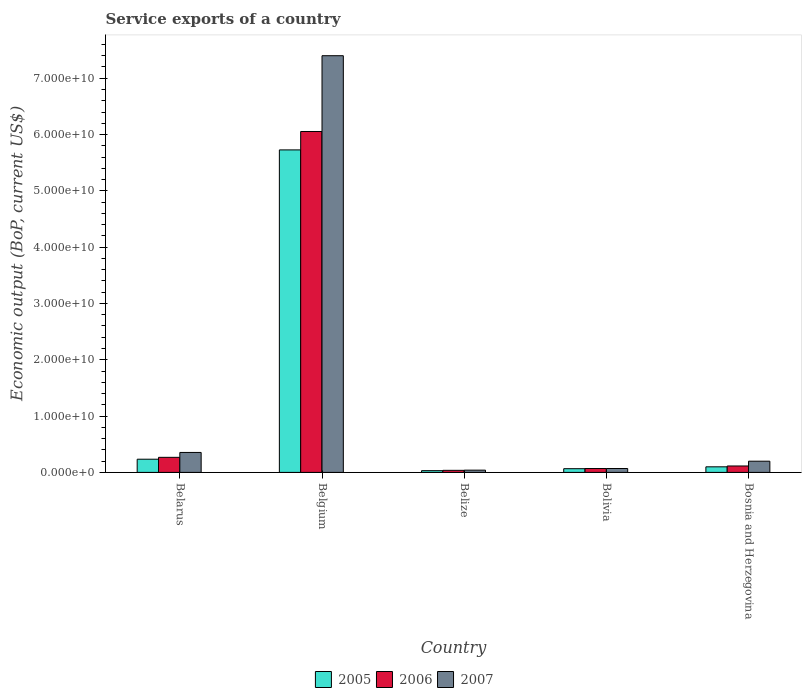How many different coloured bars are there?
Offer a very short reply. 3. How many groups of bars are there?
Provide a short and direct response. 5. Are the number of bars on each tick of the X-axis equal?
Provide a short and direct response. Yes. In how many cases, is the number of bars for a given country not equal to the number of legend labels?
Offer a very short reply. 0. What is the service exports in 2005 in Belgium?
Your answer should be compact. 5.73e+1. Across all countries, what is the maximum service exports in 2006?
Ensure brevity in your answer.  6.05e+1. Across all countries, what is the minimum service exports in 2006?
Ensure brevity in your answer.  3.67e+08. In which country was the service exports in 2007 maximum?
Give a very brief answer. Belgium. In which country was the service exports in 2005 minimum?
Your response must be concise. Belize. What is the total service exports in 2006 in the graph?
Your answer should be very brief. 6.54e+1. What is the difference between the service exports in 2007 in Belarus and that in Bolivia?
Your answer should be very brief. 2.85e+09. What is the difference between the service exports in 2007 in Bosnia and Herzegovina and the service exports in 2006 in Belize?
Provide a short and direct response. 1.62e+09. What is the average service exports in 2007 per country?
Keep it short and to the point. 1.61e+1. What is the difference between the service exports of/in 2006 and service exports of/in 2007 in Belize?
Your response must be concise. -3.31e+07. What is the ratio of the service exports in 2005 in Belarus to that in Belgium?
Offer a very short reply. 0.04. What is the difference between the highest and the second highest service exports in 2005?
Offer a very short reply. 1.35e+09. What is the difference between the highest and the lowest service exports in 2005?
Make the answer very short. 5.70e+1. Is the sum of the service exports in 2007 in Belarus and Belize greater than the maximum service exports in 2005 across all countries?
Your answer should be compact. No. What does the 2nd bar from the left in Bosnia and Herzegovina represents?
Provide a succinct answer. 2006. What does the 1st bar from the right in Bosnia and Herzegovina represents?
Your answer should be compact. 2007. Is it the case that in every country, the sum of the service exports in 2005 and service exports in 2007 is greater than the service exports in 2006?
Offer a very short reply. Yes. How many bars are there?
Your answer should be very brief. 15. How many countries are there in the graph?
Provide a succinct answer. 5. What is the difference between two consecutive major ticks on the Y-axis?
Your answer should be very brief. 1.00e+1. Are the values on the major ticks of Y-axis written in scientific E-notation?
Your answer should be very brief. Yes. Does the graph contain grids?
Provide a short and direct response. No. How are the legend labels stacked?
Offer a terse response. Horizontal. What is the title of the graph?
Your answer should be compact. Service exports of a country. Does "2008" appear as one of the legend labels in the graph?
Ensure brevity in your answer.  No. What is the label or title of the X-axis?
Make the answer very short. Country. What is the label or title of the Y-axis?
Make the answer very short. Economic output (BoP, current US$). What is the Economic output (BoP, current US$) of 2005 in Belarus?
Ensure brevity in your answer.  2.34e+09. What is the Economic output (BoP, current US$) of 2006 in Belarus?
Your answer should be compact. 2.67e+09. What is the Economic output (BoP, current US$) of 2007 in Belarus?
Provide a succinct answer. 3.54e+09. What is the Economic output (BoP, current US$) in 2005 in Belgium?
Make the answer very short. 5.73e+1. What is the Economic output (BoP, current US$) of 2006 in Belgium?
Your answer should be very brief. 6.05e+1. What is the Economic output (BoP, current US$) of 2007 in Belgium?
Give a very brief answer. 7.40e+1. What is the Economic output (BoP, current US$) of 2005 in Belize?
Give a very brief answer. 3.07e+08. What is the Economic output (BoP, current US$) of 2006 in Belize?
Your response must be concise. 3.67e+08. What is the Economic output (BoP, current US$) of 2007 in Belize?
Make the answer very short. 4.00e+08. What is the Economic output (BoP, current US$) of 2005 in Bolivia?
Offer a very short reply. 6.57e+08. What is the Economic output (BoP, current US$) in 2006 in Bolivia?
Your answer should be compact. 6.87e+08. What is the Economic output (BoP, current US$) of 2007 in Bolivia?
Offer a terse response. 6.92e+08. What is the Economic output (BoP, current US$) of 2005 in Bosnia and Herzegovina?
Give a very brief answer. 9.89e+08. What is the Economic output (BoP, current US$) in 2006 in Bosnia and Herzegovina?
Give a very brief answer. 1.14e+09. What is the Economic output (BoP, current US$) of 2007 in Bosnia and Herzegovina?
Offer a terse response. 1.99e+09. Across all countries, what is the maximum Economic output (BoP, current US$) in 2005?
Give a very brief answer. 5.73e+1. Across all countries, what is the maximum Economic output (BoP, current US$) of 2006?
Your answer should be compact. 6.05e+1. Across all countries, what is the maximum Economic output (BoP, current US$) in 2007?
Make the answer very short. 7.40e+1. Across all countries, what is the minimum Economic output (BoP, current US$) of 2005?
Your answer should be very brief. 3.07e+08. Across all countries, what is the minimum Economic output (BoP, current US$) of 2006?
Offer a very short reply. 3.67e+08. Across all countries, what is the minimum Economic output (BoP, current US$) in 2007?
Make the answer very short. 4.00e+08. What is the total Economic output (BoP, current US$) of 2005 in the graph?
Provide a short and direct response. 6.16e+1. What is the total Economic output (BoP, current US$) in 2006 in the graph?
Provide a succinct answer. 6.54e+1. What is the total Economic output (BoP, current US$) of 2007 in the graph?
Provide a short and direct response. 8.06e+1. What is the difference between the Economic output (BoP, current US$) of 2005 in Belarus and that in Belgium?
Make the answer very short. -5.49e+1. What is the difference between the Economic output (BoP, current US$) of 2006 in Belarus and that in Belgium?
Make the answer very short. -5.79e+1. What is the difference between the Economic output (BoP, current US$) in 2007 in Belarus and that in Belgium?
Offer a very short reply. -7.05e+1. What is the difference between the Economic output (BoP, current US$) of 2005 in Belarus and that in Belize?
Make the answer very short. 2.04e+09. What is the difference between the Economic output (BoP, current US$) in 2006 in Belarus and that in Belize?
Offer a very short reply. 2.31e+09. What is the difference between the Economic output (BoP, current US$) in 2007 in Belarus and that in Belize?
Provide a short and direct response. 3.14e+09. What is the difference between the Economic output (BoP, current US$) in 2005 in Belarus and that in Bolivia?
Your answer should be compact. 1.69e+09. What is the difference between the Economic output (BoP, current US$) of 2006 in Belarus and that in Bolivia?
Give a very brief answer. 1.99e+09. What is the difference between the Economic output (BoP, current US$) of 2007 in Belarus and that in Bolivia?
Provide a succinct answer. 2.85e+09. What is the difference between the Economic output (BoP, current US$) in 2005 in Belarus and that in Bosnia and Herzegovina?
Your answer should be compact. 1.35e+09. What is the difference between the Economic output (BoP, current US$) in 2006 in Belarus and that in Bosnia and Herzegovina?
Give a very brief answer. 1.53e+09. What is the difference between the Economic output (BoP, current US$) in 2007 in Belarus and that in Bosnia and Herzegovina?
Offer a terse response. 1.55e+09. What is the difference between the Economic output (BoP, current US$) in 2005 in Belgium and that in Belize?
Your answer should be very brief. 5.70e+1. What is the difference between the Economic output (BoP, current US$) of 2006 in Belgium and that in Belize?
Your answer should be very brief. 6.02e+1. What is the difference between the Economic output (BoP, current US$) in 2007 in Belgium and that in Belize?
Your response must be concise. 7.36e+1. What is the difference between the Economic output (BoP, current US$) of 2005 in Belgium and that in Bolivia?
Provide a succinct answer. 5.66e+1. What is the difference between the Economic output (BoP, current US$) of 2006 in Belgium and that in Bolivia?
Your answer should be compact. 5.99e+1. What is the difference between the Economic output (BoP, current US$) in 2007 in Belgium and that in Bolivia?
Keep it short and to the point. 7.33e+1. What is the difference between the Economic output (BoP, current US$) in 2005 in Belgium and that in Bosnia and Herzegovina?
Make the answer very short. 5.63e+1. What is the difference between the Economic output (BoP, current US$) in 2006 in Belgium and that in Bosnia and Herzegovina?
Your answer should be compact. 5.94e+1. What is the difference between the Economic output (BoP, current US$) of 2007 in Belgium and that in Bosnia and Herzegovina?
Provide a short and direct response. 7.20e+1. What is the difference between the Economic output (BoP, current US$) in 2005 in Belize and that in Bolivia?
Your response must be concise. -3.50e+08. What is the difference between the Economic output (BoP, current US$) of 2006 in Belize and that in Bolivia?
Your answer should be compact. -3.20e+08. What is the difference between the Economic output (BoP, current US$) in 2007 in Belize and that in Bolivia?
Provide a short and direct response. -2.92e+08. What is the difference between the Economic output (BoP, current US$) of 2005 in Belize and that in Bosnia and Herzegovina?
Your answer should be compact. -6.82e+08. What is the difference between the Economic output (BoP, current US$) in 2006 in Belize and that in Bosnia and Herzegovina?
Your response must be concise. -7.73e+08. What is the difference between the Economic output (BoP, current US$) in 2007 in Belize and that in Bosnia and Herzegovina?
Your answer should be very brief. -1.59e+09. What is the difference between the Economic output (BoP, current US$) in 2005 in Bolivia and that in Bosnia and Herzegovina?
Your response must be concise. -3.32e+08. What is the difference between the Economic output (BoP, current US$) of 2006 in Bolivia and that in Bosnia and Herzegovina?
Your answer should be compact. -4.52e+08. What is the difference between the Economic output (BoP, current US$) of 2007 in Bolivia and that in Bosnia and Herzegovina?
Provide a short and direct response. -1.30e+09. What is the difference between the Economic output (BoP, current US$) in 2005 in Belarus and the Economic output (BoP, current US$) in 2006 in Belgium?
Your response must be concise. -5.82e+1. What is the difference between the Economic output (BoP, current US$) in 2005 in Belarus and the Economic output (BoP, current US$) in 2007 in Belgium?
Offer a terse response. -7.17e+1. What is the difference between the Economic output (BoP, current US$) of 2006 in Belarus and the Economic output (BoP, current US$) of 2007 in Belgium?
Keep it short and to the point. -7.13e+1. What is the difference between the Economic output (BoP, current US$) in 2005 in Belarus and the Economic output (BoP, current US$) in 2006 in Belize?
Ensure brevity in your answer.  1.98e+09. What is the difference between the Economic output (BoP, current US$) of 2005 in Belarus and the Economic output (BoP, current US$) of 2007 in Belize?
Give a very brief answer. 1.94e+09. What is the difference between the Economic output (BoP, current US$) of 2006 in Belarus and the Economic output (BoP, current US$) of 2007 in Belize?
Offer a very short reply. 2.27e+09. What is the difference between the Economic output (BoP, current US$) in 2005 in Belarus and the Economic output (BoP, current US$) in 2006 in Bolivia?
Ensure brevity in your answer.  1.65e+09. What is the difference between the Economic output (BoP, current US$) in 2005 in Belarus and the Economic output (BoP, current US$) in 2007 in Bolivia?
Offer a very short reply. 1.65e+09. What is the difference between the Economic output (BoP, current US$) of 2006 in Belarus and the Economic output (BoP, current US$) of 2007 in Bolivia?
Offer a very short reply. 1.98e+09. What is the difference between the Economic output (BoP, current US$) in 2005 in Belarus and the Economic output (BoP, current US$) in 2006 in Bosnia and Herzegovina?
Make the answer very short. 1.20e+09. What is the difference between the Economic output (BoP, current US$) in 2005 in Belarus and the Economic output (BoP, current US$) in 2007 in Bosnia and Herzegovina?
Make the answer very short. 3.54e+08. What is the difference between the Economic output (BoP, current US$) of 2006 in Belarus and the Economic output (BoP, current US$) of 2007 in Bosnia and Herzegovina?
Provide a short and direct response. 6.85e+08. What is the difference between the Economic output (BoP, current US$) of 2005 in Belgium and the Economic output (BoP, current US$) of 2006 in Belize?
Your answer should be compact. 5.69e+1. What is the difference between the Economic output (BoP, current US$) of 2005 in Belgium and the Economic output (BoP, current US$) of 2007 in Belize?
Give a very brief answer. 5.69e+1. What is the difference between the Economic output (BoP, current US$) of 2006 in Belgium and the Economic output (BoP, current US$) of 2007 in Belize?
Your response must be concise. 6.01e+1. What is the difference between the Economic output (BoP, current US$) of 2005 in Belgium and the Economic output (BoP, current US$) of 2006 in Bolivia?
Your response must be concise. 5.66e+1. What is the difference between the Economic output (BoP, current US$) of 2005 in Belgium and the Economic output (BoP, current US$) of 2007 in Bolivia?
Ensure brevity in your answer.  5.66e+1. What is the difference between the Economic output (BoP, current US$) in 2006 in Belgium and the Economic output (BoP, current US$) in 2007 in Bolivia?
Ensure brevity in your answer.  5.99e+1. What is the difference between the Economic output (BoP, current US$) in 2005 in Belgium and the Economic output (BoP, current US$) in 2006 in Bosnia and Herzegovina?
Make the answer very short. 5.61e+1. What is the difference between the Economic output (BoP, current US$) of 2005 in Belgium and the Economic output (BoP, current US$) of 2007 in Bosnia and Herzegovina?
Make the answer very short. 5.53e+1. What is the difference between the Economic output (BoP, current US$) of 2006 in Belgium and the Economic output (BoP, current US$) of 2007 in Bosnia and Herzegovina?
Ensure brevity in your answer.  5.86e+1. What is the difference between the Economic output (BoP, current US$) of 2005 in Belize and the Economic output (BoP, current US$) of 2006 in Bolivia?
Your response must be concise. -3.80e+08. What is the difference between the Economic output (BoP, current US$) of 2005 in Belize and the Economic output (BoP, current US$) of 2007 in Bolivia?
Offer a terse response. -3.85e+08. What is the difference between the Economic output (BoP, current US$) of 2006 in Belize and the Economic output (BoP, current US$) of 2007 in Bolivia?
Your answer should be compact. -3.25e+08. What is the difference between the Economic output (BoP, current US$) in 2005 in Belize and the Economic output (BoP, current US$) in 2006 in Bosnia and Herzegovina?
Ensure brevity in your answer.  -8.33e+08. What is the difference between the Economic output (BoP, current US$) in 2005 in Belize and the Economic output (BoP, current US$) in 2007 in Bosnia and Herzegovina?
Your answer should be very brief. -1.68e+09. What is the difference between the Economic output (BoP, current US$) of 2006 in Belize and the Economic output (BoP, current US$) of 2007 in Bosnia and Herzegovina?
Provide a short and direct response. -1.62e+09. What is the difference between the Economic output (BoP, current US$) in 2005 in Bolivia and the Economic output (BoP, current US$) in 2006 in Bosnia and Herzegovina?
Keep it short and to the point. -4.83e+08. What is the difference between the Economic output (BoP, current US$) of 2005 in Bolivia and the Economic output (BoP, current US$) of 2007 in Bosnia and Herzegovina?
Your response must be concise. -1.33e+09. What is the difference between the Economic output (BoP, current US$) in 2006 in Bolivia and the Economic output (BoP, current US$) in 2007 in Bosnia and Herzegovina?
Offer a terse response. -1.30e+09. What is the average Economic output (BoP, current US$) in 2005 per country?
Your response must be concise. 1.23e+1. What is the average Economic output (BoP, current US$) of 2006 per country?
Offer a very short reply. 1.31e+1. What is the average Economic output (BoP, current US$) of 2007 per country?
Offer a very short reply. 1.61e+1. What is the difference between the Economic output (BoP, current US$) in 2005 and Economic output (BoP, current US$) in 2006 in Belarus?
Your answer should be compact. -3.31e+08. What is the difference between the Economic output (BoP, current US$) in 2005 and Economic output (BoP, current US$) in 2007 in Belarus?
Offer a terse response. -1.20e+09. What is the difference between the Economic output (BoP, current US$) in 2006 and Economic output (BoP, current US$) in 2007 in Belarus?
Offer a terse response. -8.68e+08. What is the difference between the Economic output (BoP, current US$) of 2005 and Economic output (BoP, current US$) of 2006 in Belgium?
Keep it short and to the point. -3.27e+09. What is the difference between the Economic output (BoP, current US$) of 2005 and Economic output (BoP, current US$) of 2007 in Belgium?
Your answer should be very brief. -1.67e+1. What is the difference between the Economic output (BoP, current US$) in 2006 and Economic output (BoP, current US$) in 2007 in Belgium?
Provide a short and direct response. -1.35e+1. What is the difference between the Economic output (BoP, current US$) in 2005 and Economic output (BoP, current US$) in 2006 in Belize?
Give a very brief answer. -6.01e+07. What is the difference between the Economic output (BoP, current US$) in 2005 and Economic output (BoP, current US$) in 2007 in Belize?
Your answer should be very brief. -9.31e+07. What is the difference between the Economic output (BoP, current US$) in 2006 and Economic output (BoP, current US$) in 2007 in Belize?
Offer a terse response. -3.31e+07. What is the difference between the Economic output (BoP, current US$) in 2005 and Economic output (BoP, current US$) in 2006 in Bolivia?
Your answer should be very brief. -3.02e+07. What is the difference between the Economic output (BoP, current US$) in 2005 and Economic output (BoP, current US$) in 2007 in Bolivia?
Your response must be concise. -3.47e+07. What is the difference between the Economic output (BoP, current US$) of 2006 and Economic output (BoP, current US$) of 2007 in Bolivia?
Ensure brevity in your answer.  -4.51e+06. What is the difference between the Economic output (BoP, current US$) of 2005 and Economic output (BoP, current US$) of 2006 in Bosnia and Herzegovina?
Make the answer very short. -1.51e+08. What is the difference between the Economic output (BoP, current US$) of 2005 and Economic output (BoP, current US$) of 2007 in Bosnia and Herzegovina?
Your answer should be compact. -1.00e+09. What is the difference between the Economic output (BoP, current US$) of 2006 and Economic output (BoP, current US$) of 2007 in Bosnia and Herzegovina?
Offer a terse response. -8.49e+08. What is the ratio of the Economic output (BoP, current US$) of 2005 in Belarus to that in Belgium?
Your response must be concise. 0.04. What is the ratio of the Economic output (BoP, current US$) of 2006 in Belarus to that in Belgium?
Your response must be concise. 0.04. What is the ratio of the Economic output (BoP, current US$) of 2007 in Belarus to that in Belgium?
Your response must be concise. 0.05. What is the ratio of the Economic output (BoP, current US$) in 2005 in Belarus to that in Belize?
Give a very brief answer. 7.63. What is the ratio of the Economic output (BoP, current US$) of 2006 in Belarus to that in Belize?
Offer a terse response. 7.28. What is the ratio of the Economic output (BoP, current US$) in 2007 in Belarus to that in Belize?
Offer a very short reply. 8.85. What is the ratio of the Economic output (BoP, current US$) of 2005 in Belarus to that in Bolivia?
Give a very brief answer. 3.56. What is the ratio of the Economic output (BoP, current US$) of 2006 in Belarus to that in Bolivia?
Ensure brevity in your answer.  3.89. What is the ratio of the Economic output (BoP, current US$) in 2007 in Belarus to that in Bolivia?
Make the answer very short. 5.12. What is the ratio of the Economic output (BoP, current US$) of 2005 in Belarus to that in Bosnia and Herzegovina?
Provide a short and direct response. 2.37. What is the ratio of the Economic output (BoP, current US$) of 2006 in Belarus to that in Bosnia and Herzegovina?
Your answer should be very brief. 2.35. What is the ratio of the Economic output (BoP, current US$) of 2007 in Belarus to that in Bosnia and Herzegovina?
Your answer should be very brief. 1.78. What is the ratio of the Economic output (BoP, current US$) of 2005 in Belgium to that in Belize?
Your response must be concise. 186.58. What is the ratio of the Economic output (BoP, current US$) of 2006 in Belgium to that in Belize?
Offer a terse response. 164.95. What is the ratio of the Economic output (BoP, current US$) in 2007 in Belgium to that in Belize?
Provide a short and direct response. 184.96. What is the ratio of the Economic output (BoP, current US$) in 2005 in Belgium to that in Bolivia?
Your answer should be compact. 87.15. What is the ratio of the Economic output (BoP, current US$) in 2006 in Belgium to that in Bolivia?
Offer a very short reply. 88.07. What is the ratio of the Economic output (BoP, current US$) of 2007 in Belgium to that in Bolivia?
Offer a very short reply. 106.95. What is the ratio of the Economic output (BoP, current US$) of 2005 in Belgium to that in Bosnia and Herzegovina?
Your answer should be compact. 57.91. What is the ratio of the Economic output (BoP, current US$) of 2006 in Belgium to that in Bosnia and Herzegovina?
Offer a terse response. 53.12. What is the ratio of the Economic output (BoP, current US$) in 2007 in Belgium to that in Bosnia and Herzegovina?
Offer a terse response. 37.21. What is the ratio of the Economic output (BoP, current US$) of 2005 in Belize to that in Bolivia?
Make the answer very short. 0.47. What is the ratio of the Economic output (BoP, current US$) of 2006 in Belize to that in Bolivia?
Give a very brief answer. 0.53. What is the ratio of the Economic output (BoP, current US$) of 2007 in Belize to that in Bolivia?
Offer a terse response. 0.58. What is the ratio of the Economic output (BoP, current US$) of 2005 in Belize to that in Bosnia and Herzegovina?
Give a very brief answer. 0.31. What is the ratio of the Economic output (BoP, current US$) of 2006 in Belize to that in Bosnia and Herzegovina?
Ensure brevity in your answer.  0.32. What is the ratio of the Economic output (BoP, current US$) in 2007 in Belize to that in Bosnia and Herzegovina?
Ensure brevity in your answer.  0.2. What is the ratio of the Economic output (BoP, current US$) of 2005 in Bolivia to that in Bosnia and Herzegovina?
Offer a very short reply. 0.66. What is the ratio of the Economic output (BoP, current US$) of 2006 in Bolivia to that in Bosnia and Herzegovina?
Provide a short and direct response. 0.6. What is the ratio of the Economic output (BoP, current US$) in 2007 in Bolivia to that in Bosnia and Herzegovina?
Keep it short and to the point. 0.35. What is the difference between the highest and the second highest Economic output (BoP, current US$) of 2005?
Offer a terse response. 5.49e+1. What is the difference between the highest and the second highest Economic output (BoP, current US$) of 2006?
Give a very brief answer. 5.79e+1. What is the difference between the highest and the second highest Economic output (BoP, current US$) in 2007?
Your answer should be very brief. 7.05e+1. What is the difference between the highest and the lowest Economic output (BoP, current US$) in 2005?
Ensure brevity in your answer.  5.70e+1. What is the difference between the highest and the lowest Economic output (BoP, current US$) in 2006?
Offer a terse response. 6.02e+1. What is the difference between the highest and the lowest Economic output (BoP, current US$) of 2007?
Your answer should be very brief. 7.36e+1. 